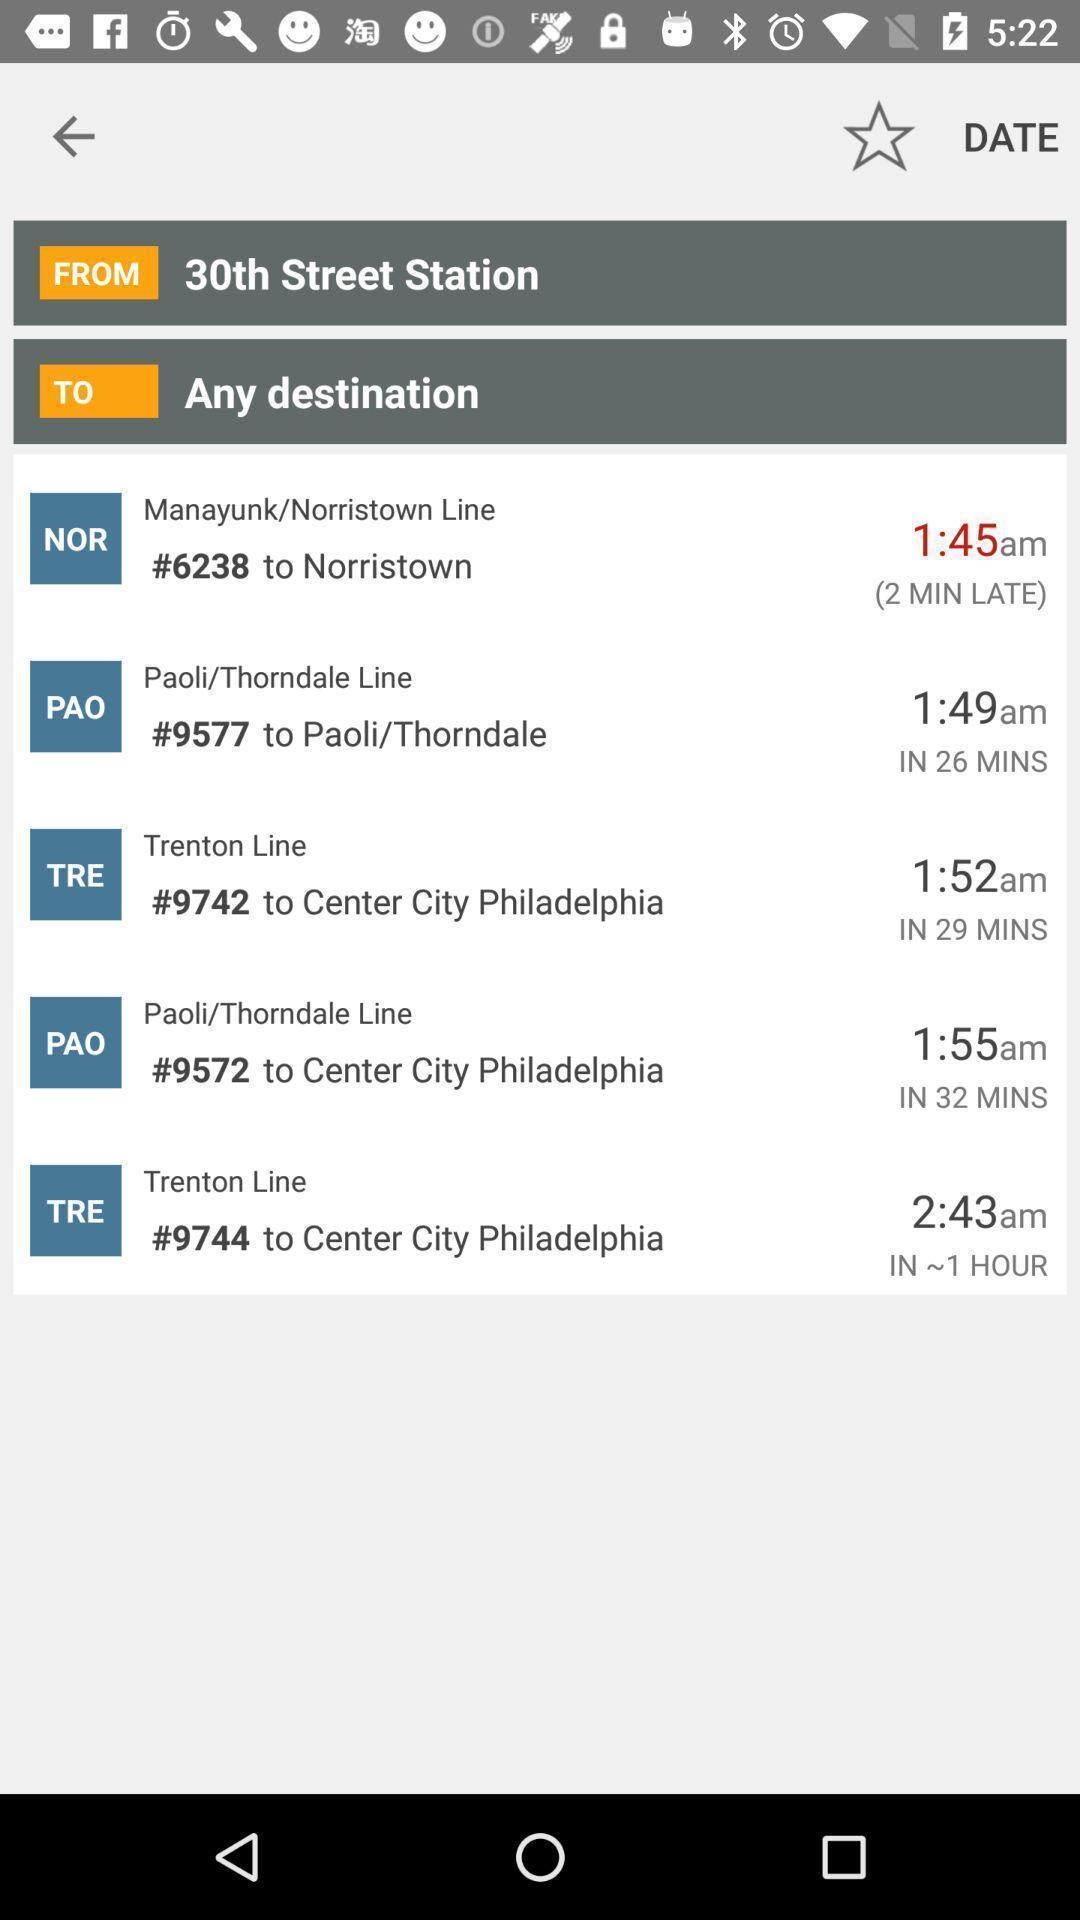Describe this image in words. Screen showing a transit app with real time schedules. 